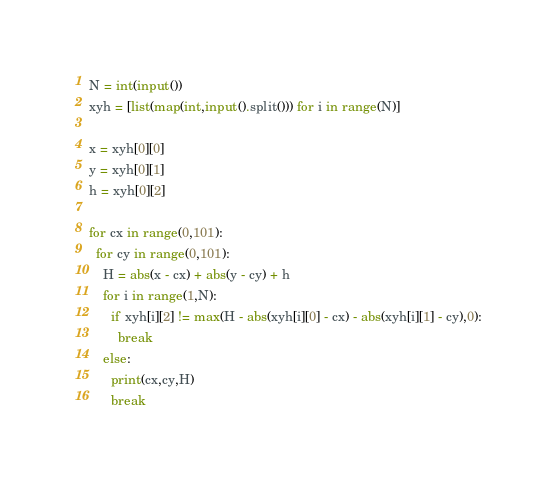<code> <loc_0><loc_0><loc_500><loc_500><_Python_>N = int(input())
xyh = [list(map(int,input().split())) for i in range(N)]

x = xyh[0][0]
y = xyh[0][1]
h = xyh[0][2]

for cx in range(0,101):
  for cy in range(0,101):
    H = abs(x - cx) + abs(y - cy) + h
    for i in range(1,N):
      if xyh[i][2] != max(H - abs(xyh[i][0] - cx) - abs(xyh[i][1] - cy),0):
        break
    else:
      print(cx,cy,H)
      break</code> 